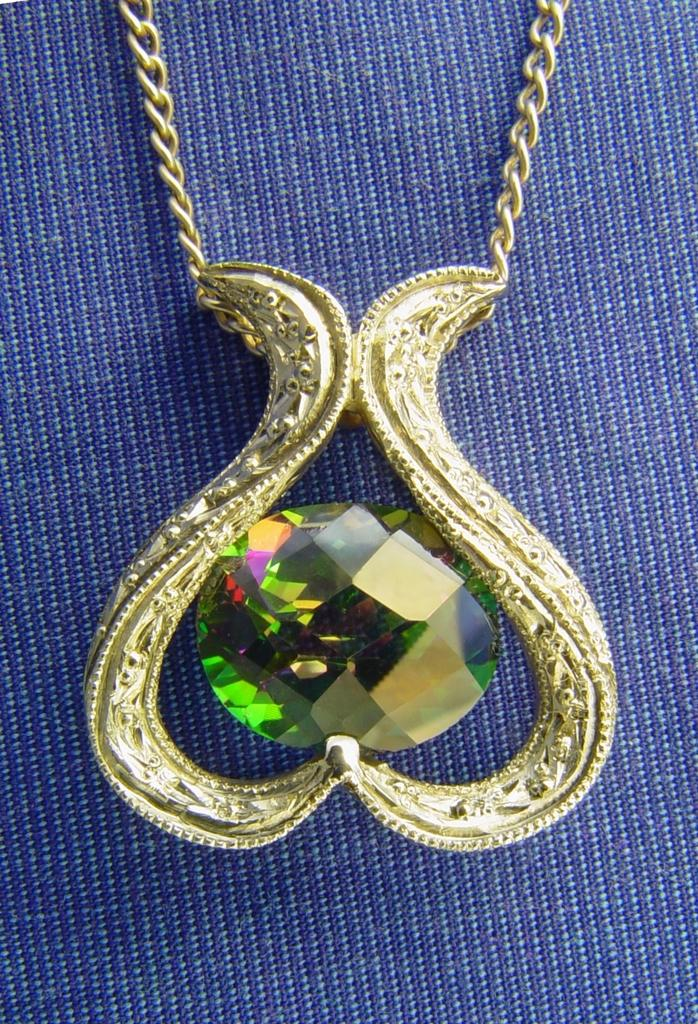What is the main object in the image? There is a chain in the image. What is attached to the chain? The chain has a pendant. What can be seen on the pendant? The pendant has some design on it. What is the background of the pendant in the image? There is a blue color cloth behind the chain. How many visitors are present in the image? There is no reference to any visitors in the image; it only features a chain with a pendant and a blue color cloth background. 